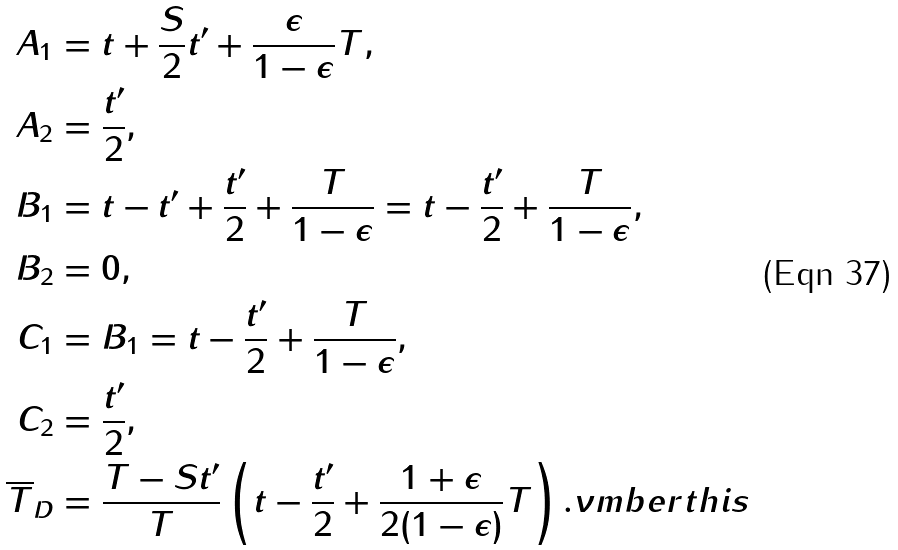<formula> <loc_0><loc_0><loc_500><loc_500>A _ { 1 } & = t + \frac { S } { 2 } t ^ { \prime } + \frac { \epsilon } { 1 - \epsilon } T , \\ A _ { 2 } & = \frac { t ^ { \prime } } { 2 } , \\ B _ { 1 } & = t - t ^ { \prime } + \frac { t ^ { \prime } } { 2 } + \frac { T } { 1 - \epsilon } = t - \frac { t ^ { \prime } } { 2 } + \frac { T } { 1 - \epsilon } , \\ B _ { 2 } & = 0 , \\ C _ { 1 } & = B _ { 1 } = t - \frac { t ^ { \prime } } { 2 } + \frac { T } { 1 - \epsilon } , \\ C _ { 2 } & = \frac { t ^ { \prime } } { 2 } , \\ \overline { T } _ { D } & = \frac { T - S t ^ { \prime } } { T } \left ( t - \frac { t ^ { \prime } } { 2 } + \frac { 1 + \epsilon } { 2 ( 1 - \epsilon ) } T \right ) . \nu m b e r t h i s</formula> 